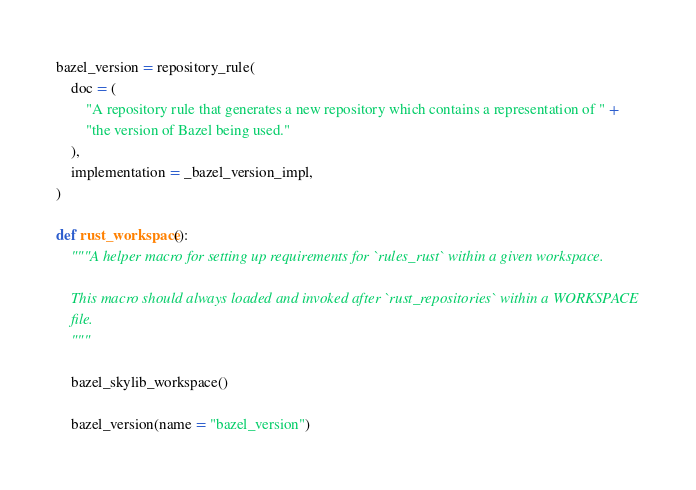Convert code to text. <code><loc_0><loc_0><loc_500><loc_500><_Python_>
bazel_version = repository_rule(
    doc = (
        "A repository rule that generates a new repository which contains a representation of " +
        "the version of Bazel being used."
    ),
    implementation = _bazel_version_impl,
)

def rust_workspace():
    """A helper macro for setting up requirements for `rules_rust` within a given workspace.

    This macro should always loaded and invoked after `rust_repositories` within a WORKSPACE
    file.
    """

    bazel_skylib_workspace()

    bazel_version(name = "bazel_version")
</code> 